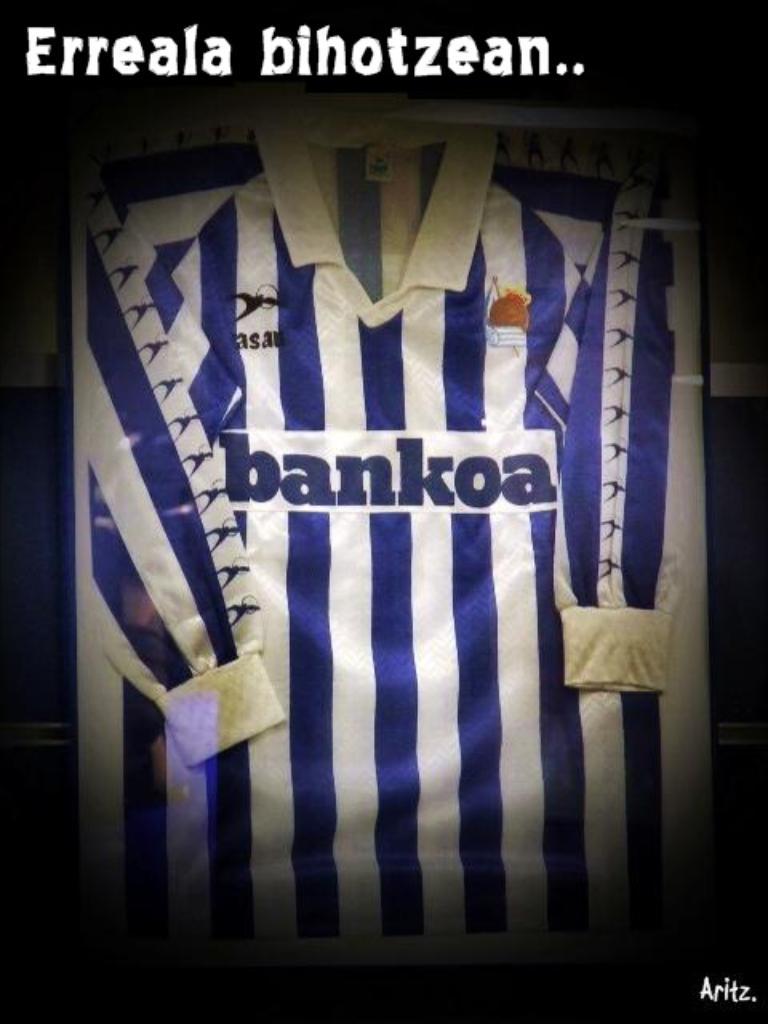What is the team's name?
Offer a terse response. Bankoa. What is the teams sponsor?
Offer a terse response. Bankoa. 